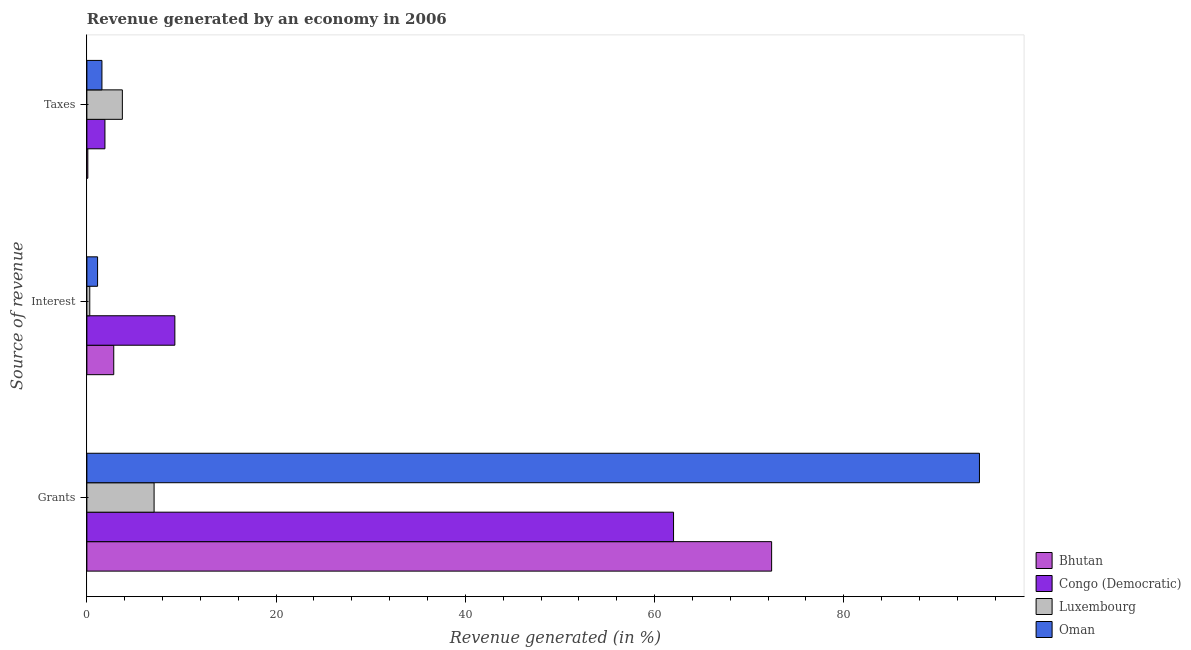How many different coloured bars are there?
Your response must be concise. 4. How many groups of bars are there?
Offer a very short reply. 3. Are the number of bars on each tick of the Y-axis equal?
Provide a succinct answer. Yes. How many bars are there on the 1st tick from the top?
Ensure brevity in your answer.  4. What is the label of the 2nd group of bars from the top?
Ensure brevity in your answer.  Interest. What is the percentage of revenue generated by interest in Oman?
Offer a very short reply. 1.13. Across all countries, what is the maximum percentage of revenue generated by grants?
Your response must be concise. 94.34. Across all countries, what is the minimum percentage of revenue generated by taxes?
Make the answer very short. 0.1. In which country was the percentage of revenue generated by taxes maximum?
Make the answer very short. Luxembourg. In which country was the percentage of revenue generated by taxes minimum?
Make the answer very short. Bhutan. What is the total percentage of revenue generated by taxes in the graph?
Make the answer very short. 7.35. What is the difference between the percentage of revenue generated by taxes in Luxembourg and that in Oman?
Offer a very short reply. 2.16. What is the difference between the percentage of revenue generated by taxes in Luxembourg and the percentage of revenue generated by interest in Bhutan?
Your answer should be very brief. 0.91. What is the average percentage of revenue generated by grants per country?
Your answer should be very brief. 58.95. What is the difference between the percentage of revenue generated by interest and percentage of revenue generated by grants in Congo (Democratic)?
Offer a very short reply. -52.71. In how many countries, is the percentage of revenue generated by taxes greater than 76 %?
Offer a terse response. 0. What is the ratio of the percentage of revenue generated by grants in Bhutan to that in Luxembourg?
Offer a terse response. 10.19. Is the percentage of revenue generated by taxes in Congo (Democratic) less than that in Bhutan?
Keep it short and to the point. No. What is the difference between the highest and the second highest percentage of revenue generated by taxes?
Ensure brevity in your answer.  1.84. What is the difference between the highest and the lowest percentage of revenue generated by taxes?
Provide a succinct answer. 3.65. Is the sum of the percentage of revenue generated by taxes in Luxembourg and Oman greater than the maximum percentage of revenue generated by interest across all countries?
Offer a terse response. No. What does the 2nd bar from the top in Taxes represents?
Your response must be concise. Luxembourg. What does the 3rd bar from the bottom in Interest represents?
Offer a very short reply. Luxembourg. Is it the case that in every country, the sum of the percentage of revenue generated by grants and percentage of revenue generated by interest is greater than the percentage of revenue generated by taxes?
Offer a terse response. Yes. How many bars are there?
Make the answer very short. 12. Are all the bars in the graph horizontal?
Your answer should be compact. Yes. How many countries are there in the graph?
Your answer should be very brief. 4. What is the title of the graph?
Give a very brief answer. Revenue generated by an economy in 2006. Does "Central African Republic" appear as one of the legend labels in the graph?
Ensure brevity in your answer.  No. What is the label or title of the X-axis?
Your response must be concise. Revenue generated (in %). What is the label or title of the Y-axis?
Make the answer very short. Source of revenue. What is the Revenue generated (in %) of Bhutan in Grants?
Provide a short and direct response. 72.37. What is the Revenue generated (in %) in Congo (Democratic) in Grants?
Provide a succinct answer. 62.01. What is the Revenue generated (in %) of Luxembourg in Grants?
Your answer should be compact. 7.1. What is the Revenue generated (in %) in Oman in Grants?
Your response must be concise. 94.34. What is the Revenue generated (in %) in Bhutan in Interest?
Ensure brevity in your answer.  2.84. What is the Revenue generated (in %) of Congo (Democratic) in Interest?
Your response must be concise. 9.3. What is the Revenue generated (in %) of Luxembourg in Interest?
Ensure brevity in your answer.  0.31. What is the Revenue generated (in %) in Oman in Interest?
Give a very brief answer. 1.13. What is the Revenue generated (in %) in Bhutan in Taxes?
Give a very brief answer. 0.1. What is the Revenue generated (in %) of Congo (Democratic) in Taxes?
Make the answer very short. 1.91. What is the Revenue generated (in %) in Luxembourg in Taxes?
Give a very brief answer. 3.75. What is the Revenue generated (in %) of Oman in Taxes?
Your answer should be compact. 1.59. Across all Source of revenue, what is the maximum Revenue generated (in %) in Bhutan?
Keep it short and to the point. 72.37. Across all Source of revenue, what is the maximum Revenue generated (in %) in Congo (Democratic)?
Offer a terse response. 62.01. Across all Source of revenue, what is the maximum Revenue generated (in %) of Luxembourg?
Offer a terse response. 7.1. Across all Source of revenue, what is the maximum Revenue generated (in %) of Oman?
Provide a succinct answer. 94.34. Across all Source of revenue, what is the minimum Revenue generated (in %) of Bhutan?
Your answer should be compact. 0.1. Across all Source of revenue, what is the minimum Revenue generated (in %) in Congo (Democratic)?
Provide a short and direct response. 1.91. Across all Source of revenue, what is the minimum Revenue generated (in %) of Luxembourg?
Provide a short and direct response. 0.31. Across all Source of revenue, what is the minimum Revenue generated (in %) of Oman?
Make the answer very short. 1.13. What is the total Revenue generated (in %) of Bhutan in the graph?
Ensure brevity in your answer.  75.31. What is the total Revenue generated (in %) in Congo (Democratic) in the graph?
Ensure brevity in your answer.  73.21. What is the total Revenue generated (in %) of Luxembourg in the graph?
Your answer should be very brief. 11.16. What is the total Revenue generated (in %) in Oman in the graph?
Your answer should be very brief. 97.06. What is the difference between the Revenue generated (in %) in Bhutan in Grants and that in Interest?
Your response must be concise. 69.53. What is the difference between the Revenue generated (in %) in Congo (Democratic) in Grants and that in Interest?
Your answer should be very brief. 52.71. What is the difference between the Revenue generated (in %) of Luxembourg in Grants and that in Interest?
Your answer should be very brief. 6.8. What is the difference between the Revenue generated (in %) of Oman in Grants and that in Interest?
Provide a succinct answer. 93.21. What is the difference between the Revenue generated (in %) of Bhutan in Grants and that in Taxes?
Keep it short and to the point. 72.27. What is the difference between the Revenue generated (in %) of Congo (Democratic) in Grants and that in Taxes?
Offer a very short reply. 60.1. What is the difference between the Revenue generated (in %) in Luxembourg in Grants and that in Taxes?
Your response must be concise. 3.35. What is the difference between the Revenue generated (in %) in Oman in Grants and that in Taxes?
Provide a succinct answer. 92.75. What is the difference between the Revenue generated (in %) in Bhutan in Interest and that in Taxes?
Offer a terse response. 2.74. What is the difference between the Revenue generated (in %) in Congo (Democratic) in Interest and that in Taxes?
Give a very brief answer. 7.39. What is the difference between the Revenue generated (in %) of Luxembourg in Interest and that in Taxes?
Offer a terse response. -3.44. What is the difference between the Revenue generated (in %) in Oman in Interest and that in Taxes?
Ensure brevity in your answer.  -0.46. What is the difference between the Revenue generated (in %) of Bhutan in Grants and the Revenue generated (in %) of Congo (Democratic) in Interest?
Make the answer very short. 63.07. What is the difference between the Revenue generated (in %) in Bhutan in Grants and the Revenue generated (in %) in Luxembourg in Interest?
Offer a terse response. 72.07. What is the difference between the Revenue generated (in %) of Bhutan in Grants and the Revenue generated (in %) of Oman in Interest?
Ensure brevity in your answer.  71.24. What is the difference between the Revenue generated (in %) in Congo (Democratic) in Grants and the Revenue generated (in %) in Luxembourg in Interest?
Give a very brief answer. 61.7. What is the difference between the Revenue generated (in %) in Congo (Democratic) in Grants and the Revenue generated (in %) in Oman in Interest?
Keep it short and to the point. 60.87. What is the difference between the Revenue generated (in %) in Luxembourg in Grants and the Revenue generated (in %) in Oman in Interest?
Give a very brief answer. 5.97. What is the difference between the Revenue generated (in %) of Bhutan in Grants and the Revenue generated (in %) of Congo (Democratic) in Taxes?
Keep it short and to the point. 70.46. What is the difference between the Revenue generated (in %) of Bhutan in Grants and the Revenue generated (in %) of Luxembourg in Taxes?
Give a very brief answer. 68.62. What is the difference between the Revenue generated (in %) of Bhutan in Grants and the Revenue generated (in %) of Oman in Taxes?
Your response must be concise. 70.78. What is the difference between the Revenue generated (in %) of Congo (Democratic) in Grants and the Revenue generated (in %) of Luxembourg in Taxes?
Your answer should be compact. 58.25. What is the difference between the Revenue generated (in %) in Congo (Democratic) in Grants and the Revenue generated (in %) in Oman in Taxes?
Offer a terse response. 60.41. What is the difference between the Revenue generated (in %) in Luxembourg in Grants and the Revenue generated (in %) in Oman in Taxes?
Provide a short and direct response. 5.51. What is the difference between the Revenue generated (in %) of Bhutan in Interest and the Revenue generated (in %) of Congo (Democratic) in Taxes?
Offer a very short reply. 0.93. What is the difference between the Revenue generated (in %) of Bhutan in Interest and the Revenue generated (in %) of Luxembourg in Taxes?
Provide a succinct answer. -0.91. What is the difference between the Revenue generated (in %) in Bhutan in Interest and the Revenue generated (in %) in Oman in Taxes?
Keep it short and to the point. 1.25. What is the difference between the Revenue generated (in %) in Congo (Democratic) in Interest and the Revenue generated (in %) in Luxembourg in Taxes?
Your response must be concise. 5.55. What is the difference between the Revenue generated (in %) in Congo (Democratic) in Interest and the Revenue generated (in %) in Oman in Taxes?
Ensure brevity in your answer.  7.71. What is the difference between the Revenue generated (in %) of Luxembourg in Interest and the Revenue generated (in %) of Oman in Taxes?
Provide a short and direct response. -1.29. What is the average Revenue generated (in %) of Bhutan per Source of revenue?
Your answer should be very brief. 25.1. What is the average Revenue generated (in %) of Congo (Democratic) per Source of revenue?
Give a very brief answer. 24.4. What is the average Revenue generated (in %) in Luxembourg per Source of revenue?
Your answer should be very brief. 3.72. What is the average Revenue generated (in %) in Oman per Source of revenue?
Provide a succinct answer. 32.35. What is the difference between the Revenue generated (in %) of Bhutan and Revenue generated (in %) of Congo (Democratic) in Grants?
Offer a very short reply. 10.37. What is the difference between the Revenue generated (in %) in Bhutan and Revenue generated (in %) in Luxembourg in Grants?
Your answer should be very brief. 65.27. What is the difference between the Revenue generated (in %) in Bhutan and Revenue generated (in %) in Oman in Grants?
Offer a very short reply. -21.97. What is the difference between the Revenue generated (in %) in Congo (Democratic) and Revenue generated (in %) in Luxembourg in Grants?
Your answer should be compact. 54.9. What is the difference between the Revenue generated (in %) in Congo (Democratic) and Revenue generated (in %) in Oman in Grants?
Provide a short and direct response. -32.33. What is the difference between the Revenue generated (in %) in Luxembourg and Revenue generated (in %) in Oman in Grants?
Make the answer very short. -87.23. What is the difference between the Revenue generated (in %) in Bhutan and Revenue generated (in %) in Congo (Democratic) in Interest?
Provide a short and direct response. -6.46. What is the difference between the Revenue generated (in %) in Bhutan and Revenue generated (in %) in Luxembourg in Interest?
Your response must be concise. 2.53. What is the difference between the Revenue generated (in %) of Bhutan and Revenue generated (in %) of Oman in Interest?
Make the answer very short. 1.71. What is the difference between the Revenue generated (in %) of Congo (Democratic) and Revenue generated (in %) of Luxembourg in Interest?
Offer a terse response. 8.99. What is the difference between the Revenue generated (in %) in Congo (Democratic) and Revenue generated (in %) in Oman in Interest?
Ensure brevity in your answer.  8.17. What is the difference between the Revenue generated (in %) in Luxembourg and Revenue generated (in %) in Oman in Interest?
Keep it short and to the point. -0.83. What is the difference between the Revenue generated (in %) of Bhutan and Revenue generated (in %) of Congo (Democratic) in Taxes?
Provide a succinct answer. -1.81. What is the difference between the Revenue generated (in %) in Bhutan and Revenue generated (in %) in Luxembourg in Taxes?
Your response must be concise. -3.65. What is the difference between the Revenue generated (in %) in Bhutan and Revenue generated (in %) in Oman in Taxes?
Give a very brief answer. -1.49. What is the difference between the Revenue generated (in %) in Congo (Democratic) and Revenue generated (in %) in Luxembourg in Taxes?
Your answer should be very brief. -1.84. What is the difference between the Revenue generated (in %) in Congo (Democratic) and Revenue generated (in %) in Oman in Taxes?
Offer a terse response. 0.32. What is the difference between the Revenue generated (in %) of Luxembourg and Revenue generated (in %) of Oman in Taxes?
Offer a terse response. 2.16. What is the ratio of the Revenue generated (in %) in Bhutan in Grants to that in Interest?
Offer a terse response. 25.48. What is the ratio of the Revenue generated (in %) in Congo (Democratic) in Grants to that in Interest?
Offer a terse response. 6.67. What is the ratio of the Revenue generated (in %) of Luxembourg in Grants to that in Interest?
Keep it short and to the point. 23.26. What is the ratio of the Revenue generated (in %) of Oman in Grants to that in Interest?
Your response must be concise. 83.36. What is the ratio of the Revenue generated (in %) of Bhutan in Grants to that in Taxes?
Keep it short and to the point. 723.57. What is the ratio of the Revenue generated (in %) in Congo (Democratic) in Grants to that in Taxes?
Give a very brief answer. 32.48. What is the ratio of the Revenue generated (in %) of Luxembourg in Grants to that in Taxes?
Your response must be concise. 1.89. What is the ratio of the Revenue generated (in %) in Oman in Grants to that in Taxes?
Offer a very short reply. 59.27. What is the ratio of the Revenue generated (in %) in Bhutan in Interest to that in Taxes?
Provide a short and direct response. 28.4. What is the ratio of the Revenue generated (in %) of Congo (Democratic) in Interest to that in Taxes?
Your answer should be very brief. 4.87. What is the ratio of the Revenue generated (in %) of Luxembourg in Interest to that in Taxes?
Your answer should be compact. 0.08. What is the ratio of the Revenue generated (in %) in Oman in Interest to that in Taxes?
Offer a very short reply. 0.71. What is the difference between the highest and the second highest Revenue generated (in %) of Bhutan?
Give a very brief answer. 69.53. What is the difference between the highest and the second highest Revenue generated (in %) of Congo (Democratic)?
Provide a succinct answer. 52.71. What is the difference between the highest and the second highest Revenue generated (in %) of Luxembourg?
Your response must be concise. 3.35. What is the difference between the highest and the second highest Revenue generated (in %) of Oman?
Your answer should be compact. 92.75. What is the difference between the highest and the lowest Revenue generated (in %) of Bhutan?
Offer a terse response. 72.27. What is the difference between the highest and the lowest Revenue generated (in %) of Congo (Democratic)?
Provide a succinct answer. 60.1. What is the difference between the highest and the lowest Revenue generated (in %) in Luxembourg?
Give a very brief answer. 6.8. What is the difference between the highest and the lowest Revenue generated (in %) of Oman?
Keep it short and to the point. 93.21. 